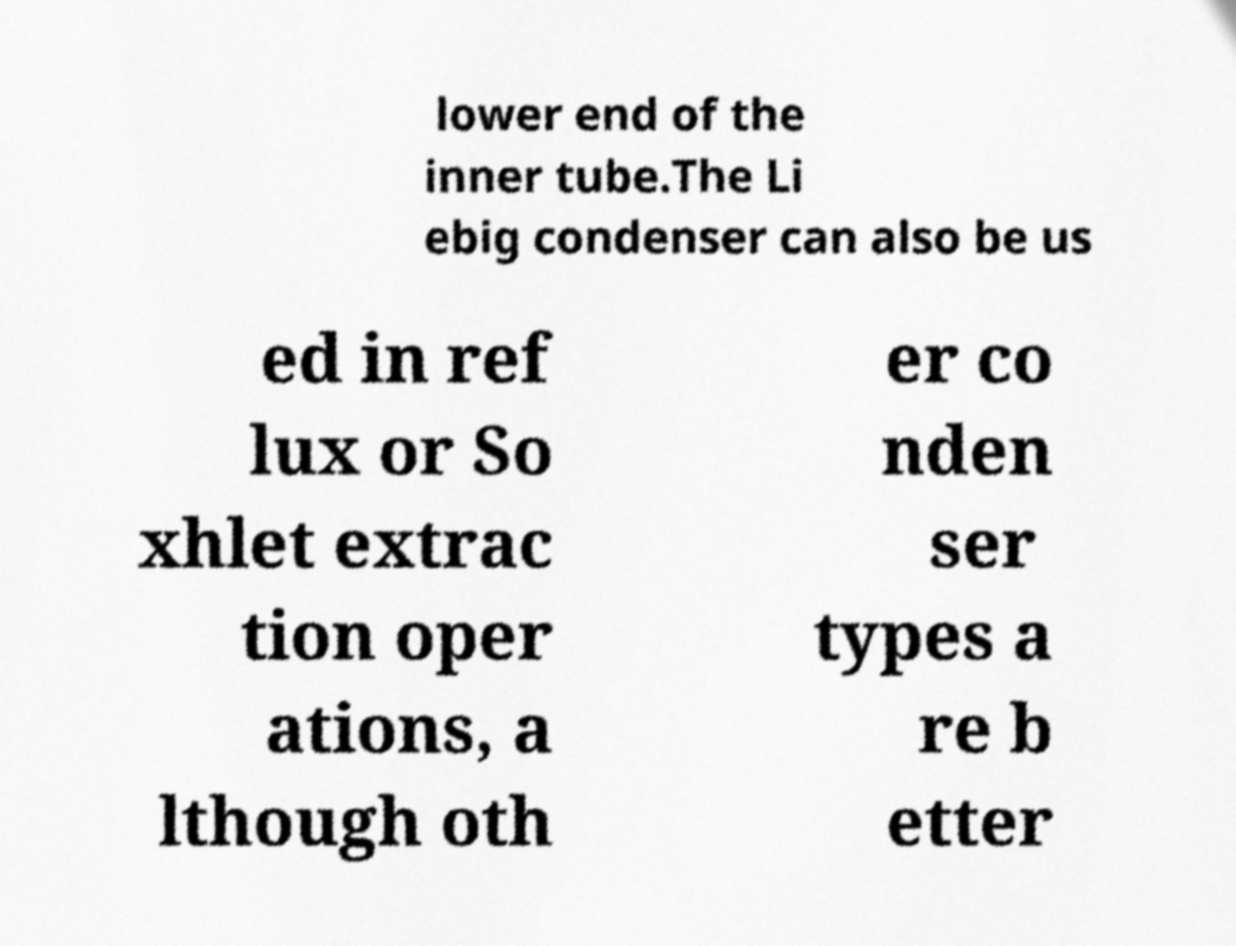Please read and relay the text visible in this image. What does it say? lower end of the inner tube.The Li ebig condenser can also be us ed in ref lux or So xhlet extrac tion oper ations, a lthough oth er co nden ser types a re b etter 